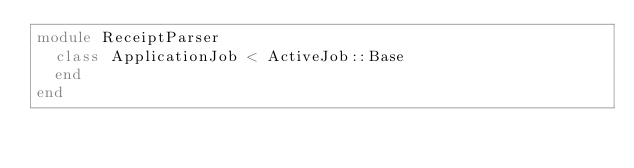Convert code to text. <code><loc_0><loc_0><loc_500><loc_500><_Ruby_>module ReceiptParser
  class ApplicationJob < ActiveJob::Base
  end
end
</code> 